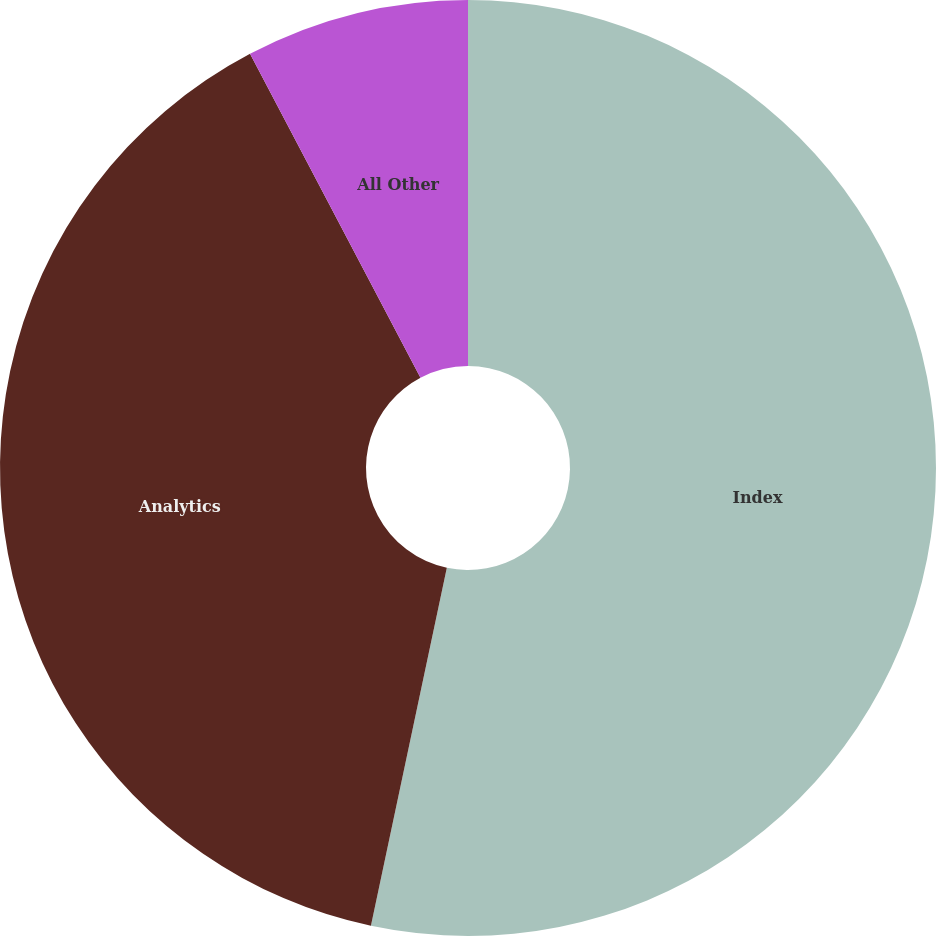Convert chart to OTSL. <chart><loc_0><loc_0><loc_500><loc_500><pie_chart><fcel>Index<fcel>Analytics<fcel>All Other<nl><fcel>53.32%<fcel>38.96%<fcel>7.71%<nl></chart> 